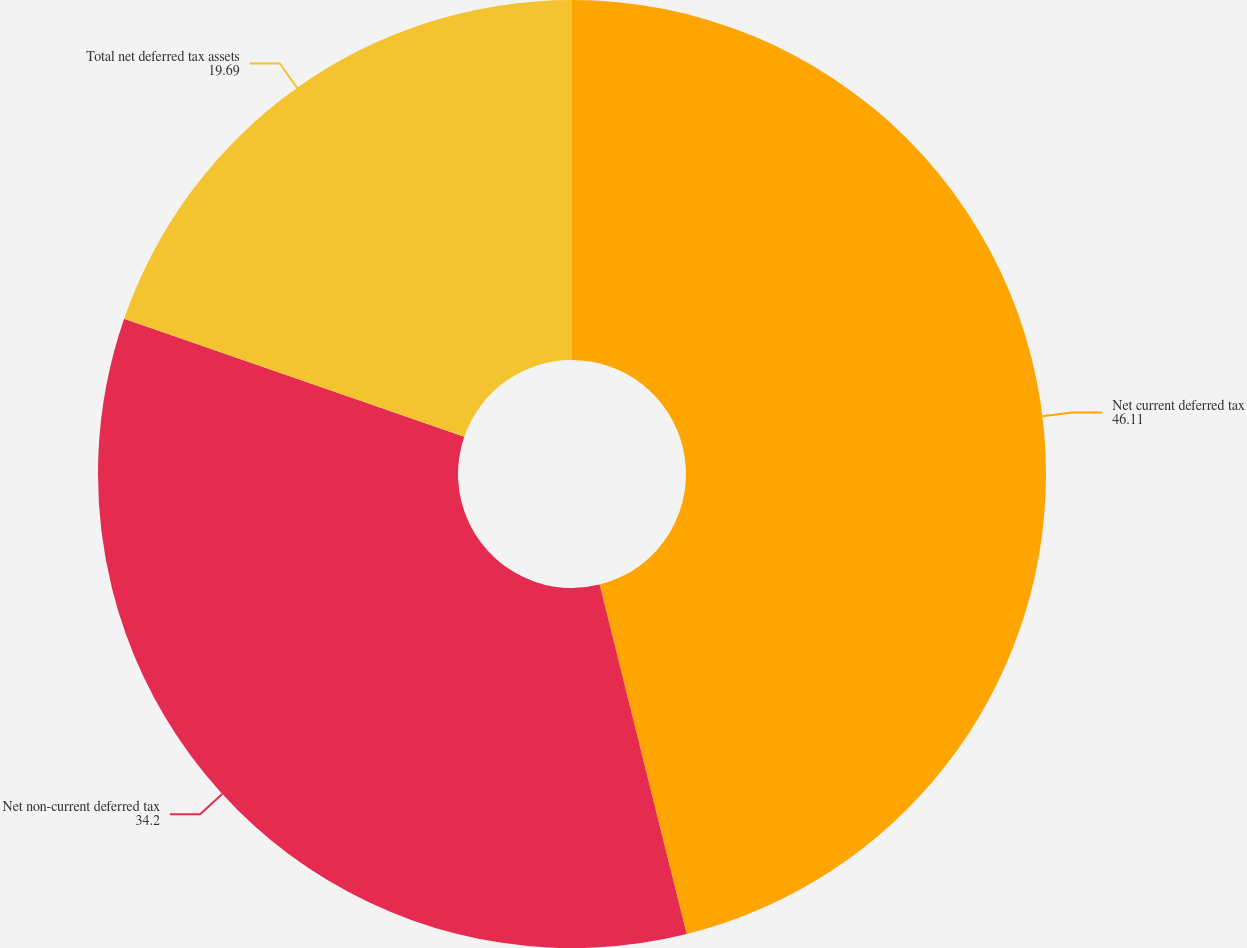Convert chart to OTSL. <chart><loc_0><loc_0><loc_500><loc_500><pie_chart><fcel>Net current deferred tax<fcel>Net non-current deferred tax<fcel>Total net deferred tax assets<nl><fcel>46.11%<fcel>34.2%<fcel>19.69%<nl></chart> 